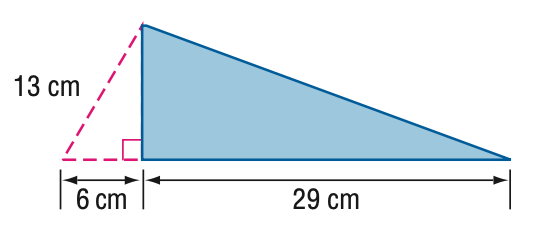Question: Find the area of the triangle.
Choices:
A. 167.2
B. 207.6
C. 334.4
D. 415.2
Answer with the letter. Answer: A Question: Find the perimeter of the triangle.
Choices:
A. 40.5
B. 60.2
C. 71.7
D. 75.7
Answer with the letter. Answer: C 